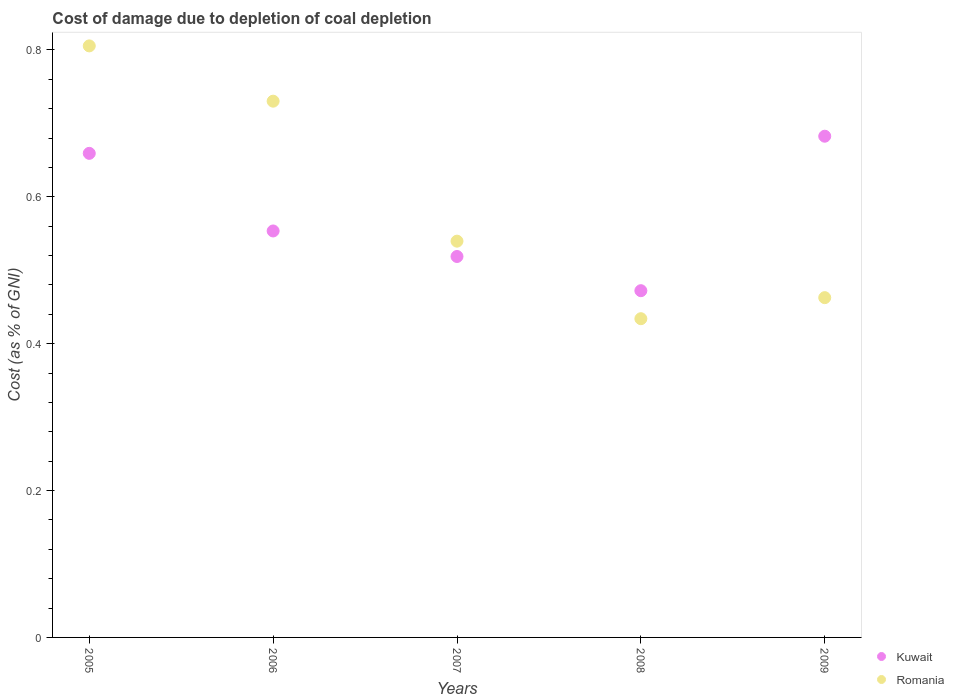Is the number of dotlines equal to the number of legend labels?
Keep it short and to the point. Yes. What is the cost of damage caused due to coal depletion in Kuwait in 2005?
Keep it short and to the point. 0.66. Across all years, what is the maximum cost of damage caused due to coal depletion in Romania?
Provide a succinct answer. 0.81. Across all years, what is the minimum cost of damage caused due to coal depletion in Romania?
Offer a terse response. 0.43. In which year was the cost of damage caused due to coal depletion in Kuwait minimum?
Provide a short and direct response. 2008. What is the total cost of damage caused due to coal depletion in Romania in the graph?
Ensure brevity in your answer.  2.97. What is the difference between the cost of damage caused due to coal depletion in Romania in 2006 and that in 2009?
Make the answer very short. 0.27. What is the difference between the cost of damage caused due to coal depletion in Kuwait in 2009 and the cost of damage caused due to coal depletion in Romania in 2007?
Provide a succinct answer. 0.14. What is the average cost of damage caused due to coal depletion in Kuwait per year?
Make the answer very short. 0.58. In the year 2009, what is the difference between the cost of damage caused due to coal depletion in Romania and cost of damage caused due to coal depletion in Kuwait?
Offer a very short reply. -0.22. In how many years, is the cost of damage caused due to coal depletion in Romania greater than 0.08 %?
Offer a terse response. 5. What is the ratio of the cost of damage caused due to coal depletion in Romania in 2005 to that in 2009?
Offer a very short reply. 1.74. What is the difference between the highest and the second highest cost of damage caused due to coal depletion in Romania?
Keep it short and to the point. 0.08. What is the difference between the highest and the lowest cost of damage caused due to coal depletion in Kuwait?
Offer a very short reply. 0.21. In how many years, is the cost of damage caused due to coal depletion in Kuwait greater than the average cost of damage caused due to coal depletion in Kuwait taken over all years?
Offer a very short reply. 2. Does the cost of damage caused due to coal depletion in Romania monotonically increase over the years?
Provide a succinct answer. No. Is the cost of damage caused due to coal depletion in Romania strictly greater than the cost of damage caused due to coal depletion in Kuwait over the years?
Offer a terse response. No. Is the cost of damage caused due to coal depletion in Romania strictly less than the cost of damage caused due to coal depletion in Kuwait over the years?
Give a very brief answer. No. How many dotlines are there?
Your response must be concise. 2. Does the graph contain any zero values?
Make the answer very short. No. Does the graph contain grids?
Your response must be concise. No. How many legend labels are there?
Make the answer very short. 2. What is the title of the graph?
Provide a short and direct response. Cost of damage due to depletion of coal depletion. Does "Afghanistan" appear as one of the legend labels in the graph?
Your answer should be compact. No. What is the label or title of the X-axis?
Offer a terse response. Years. What is the label or title of the Y-axis?
Ensure brevity in your answer.  Cost (as % of GNI). What is the Cost (as % of GNI) in Kuwait in 2005?
Offer a very short reply. 0.66. What is the Cost (as % of GNI) in Romania in 2005?
Your answer should be very brief. 0.81. What is the Cost (as % of GNI) of Kuwait in 2006?
Provide a short and direct response. 0.55. What is the Cost (as % of GNI) in Romania in 2006?
Offer a very short reply. 0.73. What is the Cost (as % of GNI) of Kuwait in 2007?
Ensure brevity in your answer.  0.52. What is the Cost (as % of GNI) in Romania in 2007?
Your answer should be very brief. 0.54. What is the Cost (as % of GNI) in Kuwait in 2008?
Make the answer very short. 0.47. What is the Cost (as % of GNI) in Romania in 2008?
Your answer should be very brief. 0.43. What is the Cost (as % of GNI) of Kuwait in 2009?
Keep it short and to the point. 0.68. What is the Cost (as % of GNI) in Romania in 2009?
Offer a terse response. 0.46. Across all years, what is the maximum Cost (as % of GNI) of Kuwait?
Provide a short and direct response. 0.68. Across all years, what is the maximum Cost (as % of GNI) of Romania?
Your answer should be compact. 0.81. Across all years, what is the minimum Cost (as % of GNI) of Kuwait?
Ensure brevity in your answer.  0.47. Across all years, what is the minimum Cost (as % of GNI) in Romania?
Provide a short and direct response. 0.43. What is the total Cost (as % of GNI) of Kuwait in the graph?
Your response must be concise. 2.89. What is the total Cost (as % of GNI) in Romania in the graph?
Give a very brief answer. 2.97. What is the difference between the Cost (as % of GNI) of Kuwait in 2005 and that in 2006?
Your response must be concise. 0.11. What is the difference between the Cost (as % of GNI) of Romania in 2005 and that in 2006?
Offer a terse response. 0.08. What is the difference between the Cost (as % of GNI) in Kuwait in 2005 and that in 2007?
Your answer should be very brief. 0.14. What is the difference between the Cost (as % of GNI) of Romania in 2005 and that in 2007?
Provide a succinct answer. 0.27. What is the difference between the Cost (as % of GNI) of Kuwait in 2005 and that in 2008?
Your answer should be compact. 0.19. What is the difference between the Cost (as % of GNI) in Romania in 2005 and that in 2008?
Give a very brief answer. 0.37. What is the difference between the Cost (as % of GNI) of Kuwait in 2005 and that in 2009?
Provide a short and direct response. -0.02. What is the difference between the Cost (as % of GNI) of Romania in 2005 and that in 2009?
Your answer should be very brief. 0.34. What is the difference between the Cost (as % of GNI) of Kuwait in 2006 and that in 2007?
Offer a terse response. 0.03. What is the difference between the Cost (as % of GNI) in Romania in 2006 and that in 2007?
Your answer should be compact. 0.19. What is the difference between the Cost (as % of GNI) of Kuwait in 2006 and that in 2008?
Your answer should be very brief. 0.08. What is the difference between the Cost (as % of GNI) of Romania in 2006 and that in 2008?
Your response must be concise. 0.3. What is the difference between the Cost (as % of GNI) in Kuwait in 2006 and that in 2009?
Your response must be concise. -0.13. What is the difference between the Cost (as % of GNI) of Romania in 2006 and that in 2009?
Offer a terse response. 0.27. What is the difference between the Cost (as % of GNI) of Kuwait in 2007 and that in 2008?
Offer a very short reply. 0.05. What is the difference between the Cost (as % of GNI) in Romania in 2007 and that in 2008?
Give a very brief answer. 0.11. What is the difference between the Cost (as % of GNI) in Kuwait in 2007 and that in 2009?
Provide a short and direct response. -0.16. What is the difference between the Cost (as % of GNI) of Romania in 2007 and that in 2009?
Give a very brief answer. 0.08. What is the difference between the Cost (as % of GNI) of Kuwait in 2008 and that in 2009?
Your answer should be very brief. -0.21. What is the difference between the Cost (as % of GNI) of Romania in 2008 and that in 2009?
Offer a very short reply. -0.03. What is the difference between the Cost (as % of GNI) of Kuwait in 2005 and the Cost (as % of GNI) of Romania in 2006?
Give a very brief answer. -0.07. What is the difference between the Cost (as % of GNI) of Kuwait in 2005 and the Cost (as % of GNI) of Romania in 2007?
Your answer should be compact. 0.12. What is the difference between the Cost (as % of GNI) of Kuwait in 2005 and the Cost (as % of GNI) of Romania in 2008?
Provide a succinct answer. 0.23. What is the difference between the Cost (as % of GNI) in Kuwait in 2005 and the Cost (as % of GNI) in Romania in 2009?
Ensure brevity in your answer.  0.2. What is the difference between the Cost (as % of GNI) of Kuwait in 2006 and the Cost (as % of GNI) of Romania in 2007?
Ensure brevity in your answer.  0.01. What is the difference between the Cost (as % of GNI) of Kuwait in 2006 and the Cost (as % of GNI) of Romania in 2008?
Offer a terse response. 0.12. What is the difference between the Cost (as % of GNI) in Kuwait in 2006 and the Cost (as % of GNI) in Romania in 2009?
Offer a terse response. 0.09. What is the difference between the Cost (as % of GNI) in Kuwait in 2007 and the Cost (as % of GNI) in Romania in 2008?
Provide a short and direct response. 0.08. What is the difference between the Cost (as % of GNI) in Kuwait in 2007 and the Cost (as % of GNI) in Romania in 2009?
Give a very brief answer. 0.06. What is the difference between the Cost (as % of GNI) in Kuwait in 2008 and the Cost (as % of GNI) in Romania in 2009?
Your response must be concise. 0.01. What is the average Cost (as % of GNI) of Kuwait per year?
Provide a succinct answer. 0.58. What is the average Cost (as % of GNI) of Romania per year?
Make the answer very short. 0.59. In the year 2005, what is the difference between the Cost (as % of GNI) in Kuwait and Cost (as % of GNI) in Romania?
Provide a short and direct response. -0.15. In the year 2006, what is the difference between the Cost (as % of GNI) in Kuwait and Cost (as % of GNI) in Romania?
Your answer should be compact. -0.18. In the year 2007, what is the difference between the Cost (as % of GNI) in Kuwait and Cost (as % of GNI) in Romania?
Your response must be concise. -0.02. In the year 2008, what is the difference between the Cost (as % of GNI) in Kuwait and Cost (as % of GNI) in Romania?
Your response must be concise. 0.04. In the year 2009, what is the difference between the Cost (as % of GNI) of Kuwait and Cost (as % of GNI) of Romania?
Provide a short and direct response. 0.22. What is the ratio of the Cost (as % of GNI) in Kuwait in 2005 to that in 2006?
Keep it short and to the point. 1.19. What is the ratio of the Cost (as % of GNI) of Romania in 2005 to that in 2006?
Your answer should be very brief. 1.1. What is the ratio of the Cost (as % of GNI) of Kuwait in 2005 to that in 2007?
Provide a succinct answer. 1.27. What is the ratio of the Cost (as % of GNI) of Romania in 2005 to that in 2007?
Your answer should be compact. 1.49. What is the ratio of the Cost (as % of GNI) in Kuwait in 2005 to that in 2008?
Offer a very short reply. 1.4. What is the ratio of the Cost (as % of GNI) of Romania in 2005 to that in 2008?
Ensure brevity in your answer.  1.86. What is the ratio of the Cost (as % of GNI) in Kuwait in 2005 to that in 2009?
Offer a terse response. 0.97. What is the ratio of the Cost (as % of GNI) in Romania in 2005 to that in 2009?
Provide a short and direct response. 1.74. What is the ratio of the Cost (as % of GNI) in Kuwait in 2006 to that in 2007?
Provide a short and direct response. 1.07. What is the ratio of the Cost (as % of GNI) of Romania in 2006 to that in 2007?
Provide a short and direct response. 1.35. What is the ratio of the Cost (as % of GNI) in Kuwait in 2006 to that in 2008?
Your response must be concise. 1.17. What is the ratio of the Cost (as % of GNI) in Romania in 2006 to that in 2008?
Offer a very short reply. 1.68. What is the ratio of the Cost (as % of GNI) in Kuwait in 2006 to that in 2009?
Your answer should be very brief. 0.81. What is the ratio of the Cost (as % of GNI) of Romania in 2006 to that in 2009?
Offer a very short reply. 1.58. What is the ratio of the Cost (as % of GNI) in Kuwait in 2007 to that in 2008?
Your response must be concise. 1.1. What is the ratio of the Cost (as % of GNI) in Romania in 2007 to that in 2008?
Your response must be concise. 1.24. What is the ratio of the Cost (as % of GNI) of Kuwait in 2007 to that in 2009?
Make the answer very short. 0.76. What is the ratio of the Cost (as % of GNI) in Romania in 2007 to that in 2009?
Make the answer very short. 1.17. What is the ratio of the Cost (as % of GNI) of Kuwait in 2008 to that in 2009?
Provide a short and direct response. 0.69. What is the ratio of the Cost (as % of GNI) in Romania in 2008 to that in 2009?
Your answer should be very brief. 0.94. What is the difference between the highest and the second highest Cost (as % of GNI) of Kuwait?
Ensure brevity in your answer.  0.02. What is the difference between the highest and the second highest Cost (as % of GNI) of Romania?
Make the answer very short. 0.08. What is the difference between the highest and the lowest Cost (as % of GNI) of Kuwait?
Your answer should be very brief. 0.21. What is the difference between the highest and the lowest Cost (as % of GNI) of Romania?
Keep it short and to the point. 0.37. 